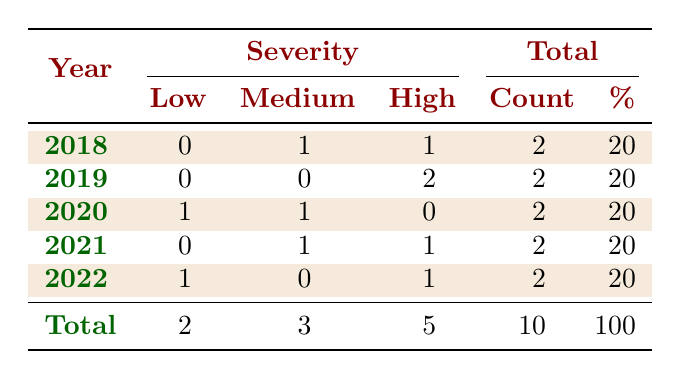What is the total count of reported environmental incidents in 2020? In the table, we look at the row for the year 2020. The column for count shows the value 2.
Answer: 2 How many incidents were reported as high severity in 2021? Referring to the row for 2021, there is 1 incident listed as high severity in the table.
Answer: 1 What is the percentage of incidents classified as low severity across all years? The table shows a total of 10 incidents, with 2 of them classified as low severity, which calculates to 2/10 x 100 = 20%.
Answer: 20% Were there any incidents classified as low severity in 2019? Checking the row for 2019, the severity column has no entries for low severity incidents.
Answer: No How many total incidents across all years were reported by local residents? By reviewing the reported by column, we find incidents from local residents in 2018 and 2021, totaling 2 incidents.
Answer: 2 What is the average count of incidents per year for high severity across the years shown? The table shows 5 high severity incidents across 5 years (2018, 2019, 2021, and 2022), so we calculate the average as 5/5 = 1.
Answer: 1 In which year was there the highest total number of reported incidents? Each year has a total of 2 incidents, thus, no single year has a higher total; they are all the same according to the table.
Answer: None Is there an incident type that was classified as medium severity more than once? Looking at the medium severity column, we see that there are 3 incidents across various years, but none of them repeats in incident type.
Answer: No What is the difference in the number of incidents between high severity and low severity? Summing up, there are 5 high severity incidents and 2 low severity incidents, the difference is 5 - 2 = 3.
Answer: 3 